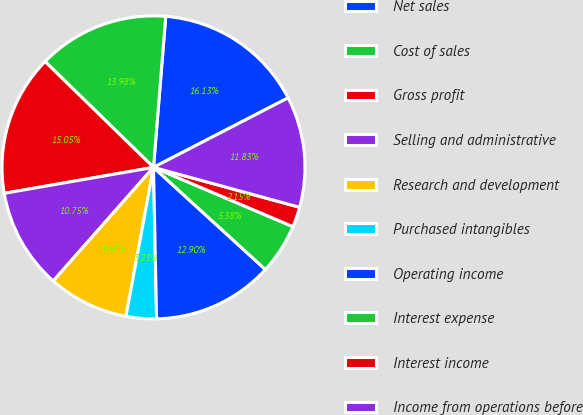<chart> <loc_0><loc_0><loc_500><loc_500><pie_chart><fcel>Net sales<fcel>Cost of sales<fcel>Gross profit<fcel>Selling and administrative<fcel>Research and development<fcel>Purchased intangibles<fcel>Operating income<fcel>Interest expense<fcel>Interest income<fcel>Income from operations before<nl><fcel>16.13%<fcel>13.98%<fcel>15.05%<fcel>10.75%<fcel>8.6%<fcel>3.23%<fcel>12.9%<fcel>5.38%<fcel>2.15%<fcel>11.83%<nl></chart> 